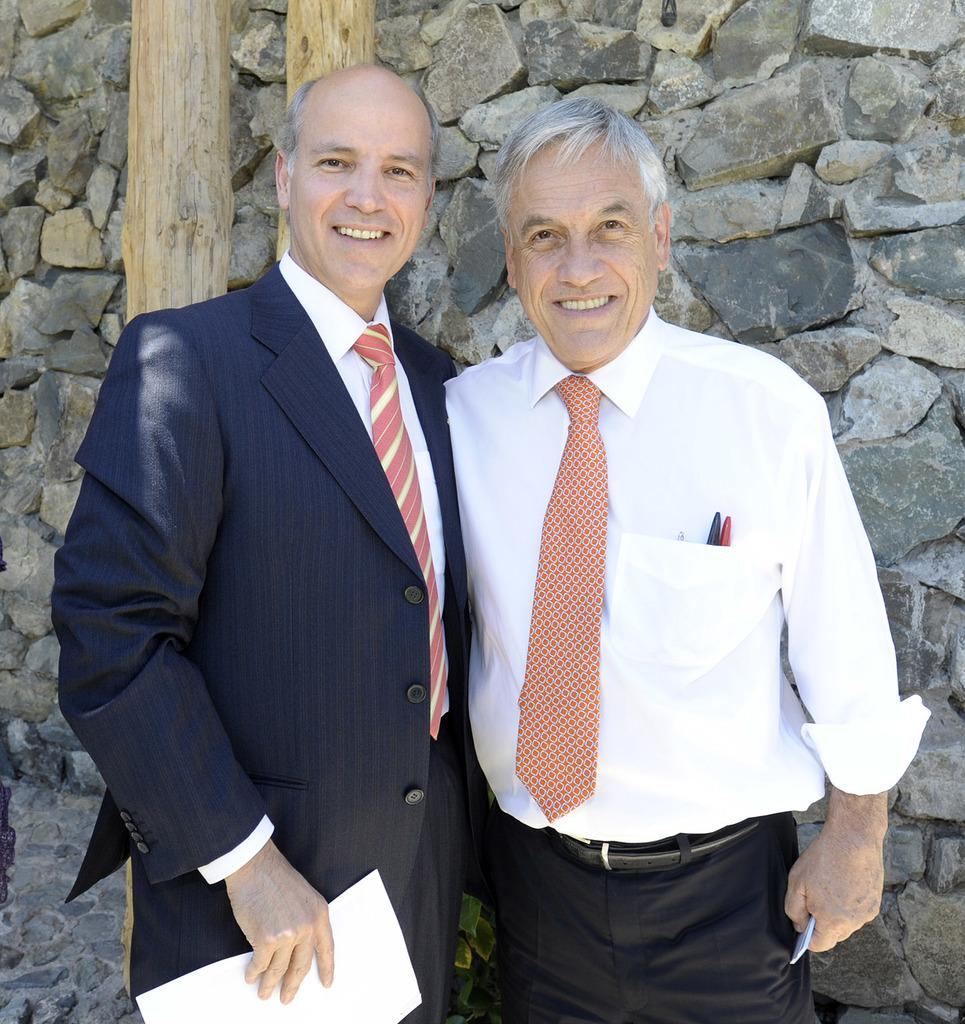How many people are in the image? There are two men standing in the image. What is the facial expression of the men in the image? The men are smiling in the image. What is one of the men holding? One man is holding a paper in the image. What type of structures can be seen in the image? There are wooden poles visible in the image. What is visible in the background of the image? There is a stone wall in the background of the image. What type of reward is the man receiving for his performance in the image? There is no indication in the image that a reward is being given or received, nor is there any performance being depicted. 